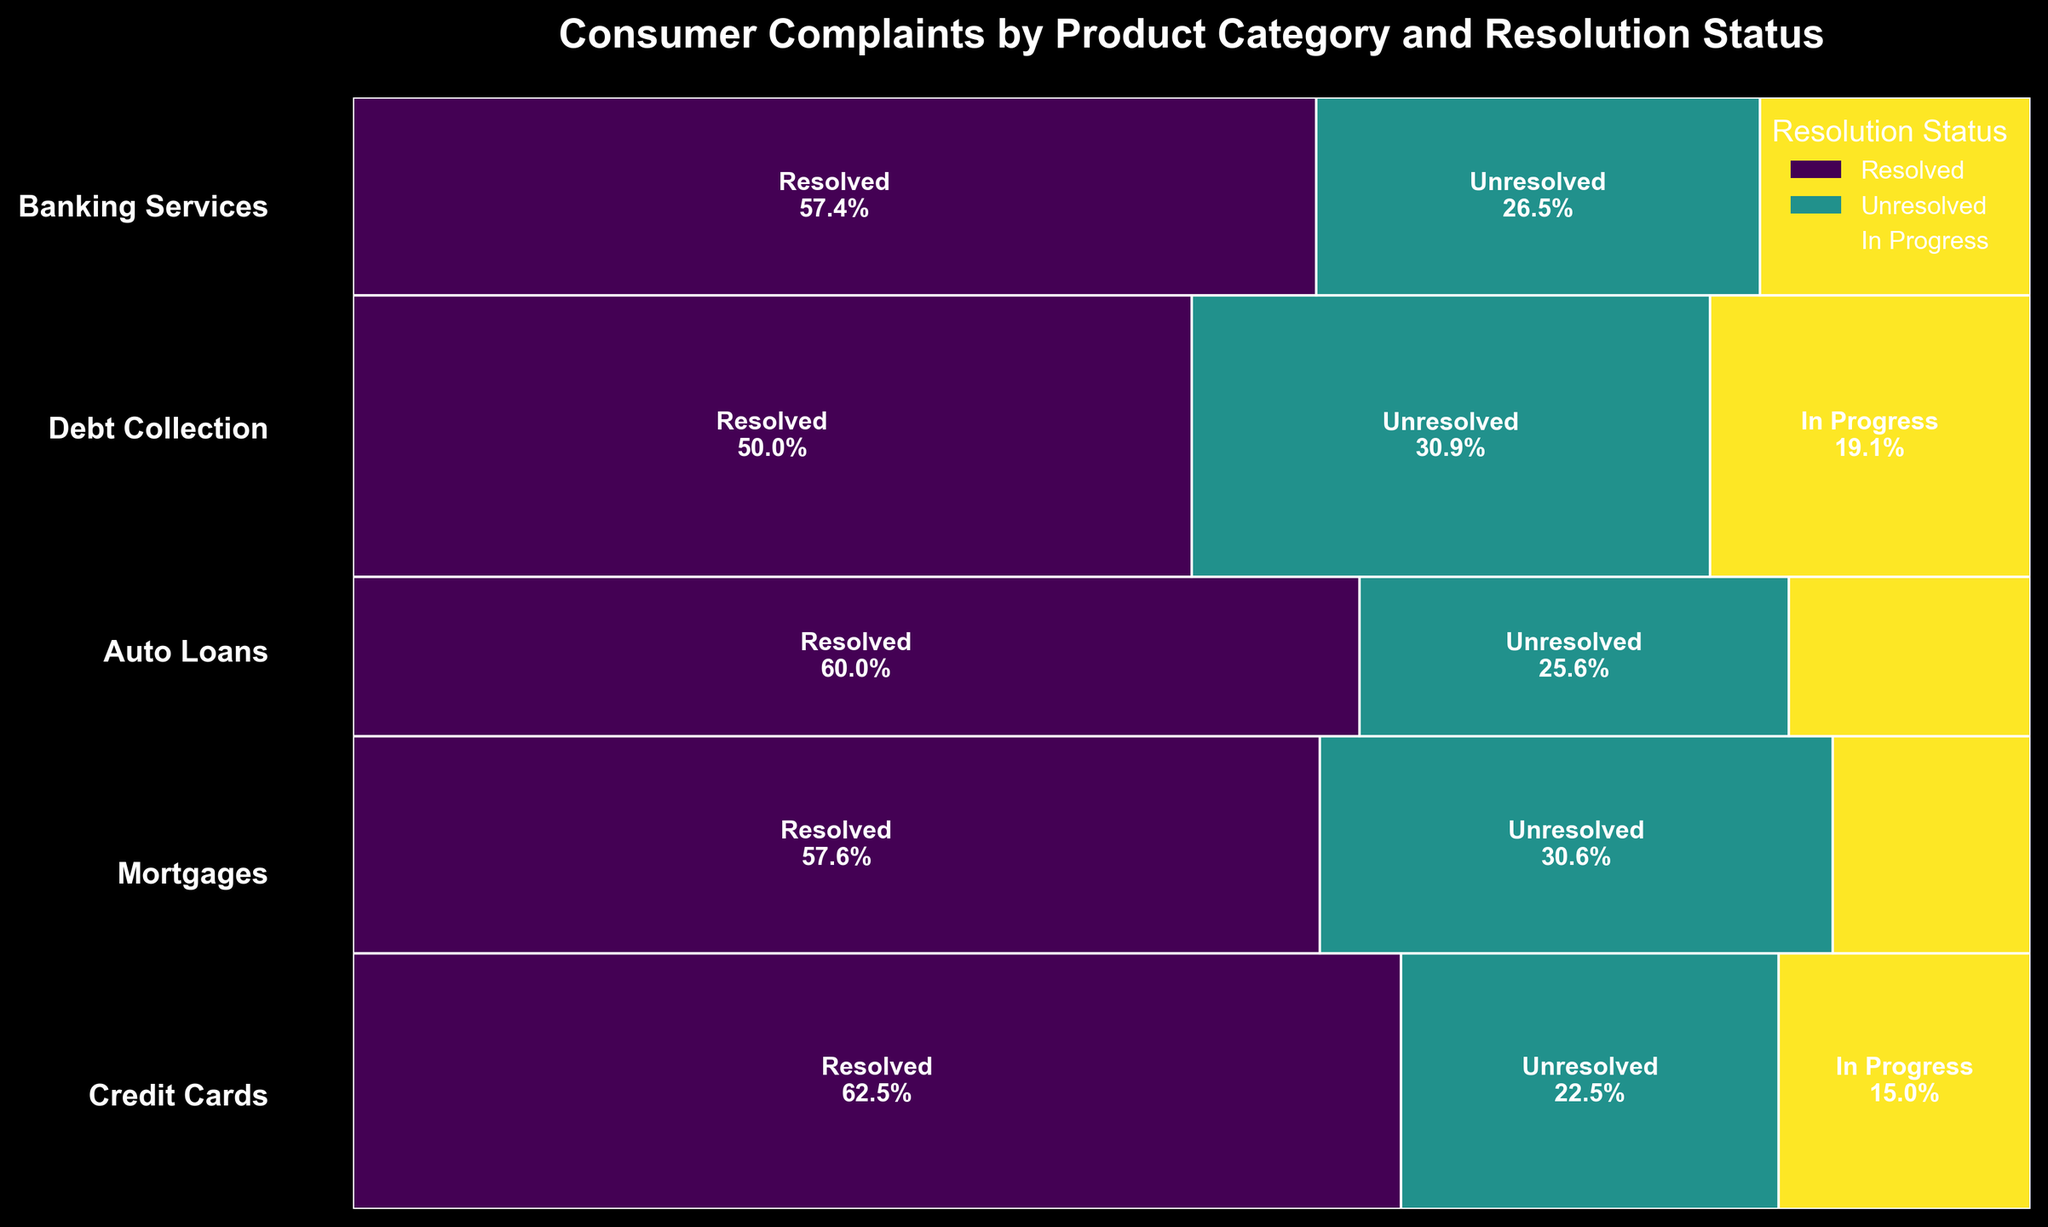What's the title of the plot? The title is usually found at the top of the plot and provides a summary of the data being visualized. In this case, the title "Consumer Complaints by Product Category and Resolution Status" succinctly describes what the plot is about.
Answer: "Consumer Complaints by Product Category and Resolution Status" Which product category has the highest number of complaints? To determine the product category with the highest number of complaints, look at the heights of the rectangles corresponding to each category. The tallest rectangle represents the product category with the most complaints.
Answer: Debt Collection What proportion of 'Credit Cards' complaints are unresolved? First, locate the 'Credit Cards' bar. Then, check the segment corresponding to 'Unresolved' and note its proportion relative to the entire 'Credit Cards' bar. The text within the segment or the width compared to the full length will give this information.
Answer: 22.5% Which product category has the greatest proportion of resolved complaints? By observing each product category, find the segments marked 'Resolved'. Identify the category where this segment takes up the most space proportionally within its bar. This indicates the category with the highest resolution rate.
Answer: Credit Cards What is the percentage difference between resolved and unresolved complaints in 'Mortgages'? Calculate the difference between the proportions of resolved and unresolved complaints for 'Mortgages', using the segments within the 'Mortgages' bar.
Answer: 29.2% Are there more unresolved complaints for 'Auto Loans' or 'Banking Services'? Compare the widths of the 'Unresolved' segments for 'Auto Loans' and 'Banking Services'. The category with the wider segment has more unresolved complaints.
Answer: Auto Loans What proportion of 'Debt Collection' complaints are still in progress? Identify the 'In Progress' segment in the 'Debt Collection' category. The proportion is indicated by the width of this segment relative to the total width of the 'Debt Collection' bar.
Answer: 20.3% Which resolution status has the second largest segment in 'Banking Services'? Look at the segments within the 'Banking Services' bar and identify which one is the second largest. This involves checking the widths and visually comparing them.
Answer: Unresolved How does the proportion of unresolved complaints in 'Credit Cards' compare to 'Debt Collection'? Compare the width of the 'Unresolved' segments between 'Credit Cards' and 'Debt Collection'. This involves visually inspecting which segment is relatively larger or smaller.
Answer: Debt Collection is larger What overall insights can you draw about the resolution of complaints across all categories? Examine all segments across categories to see patterns, e.g., which statuses (Resolved, Unresolved, In Progress) are most common. Identify if certain categories have a notably higher resolution rate or more unresolved issues.
Answer: Varied resolutions; some categories resolve more complaints while others have many unresolved cases 